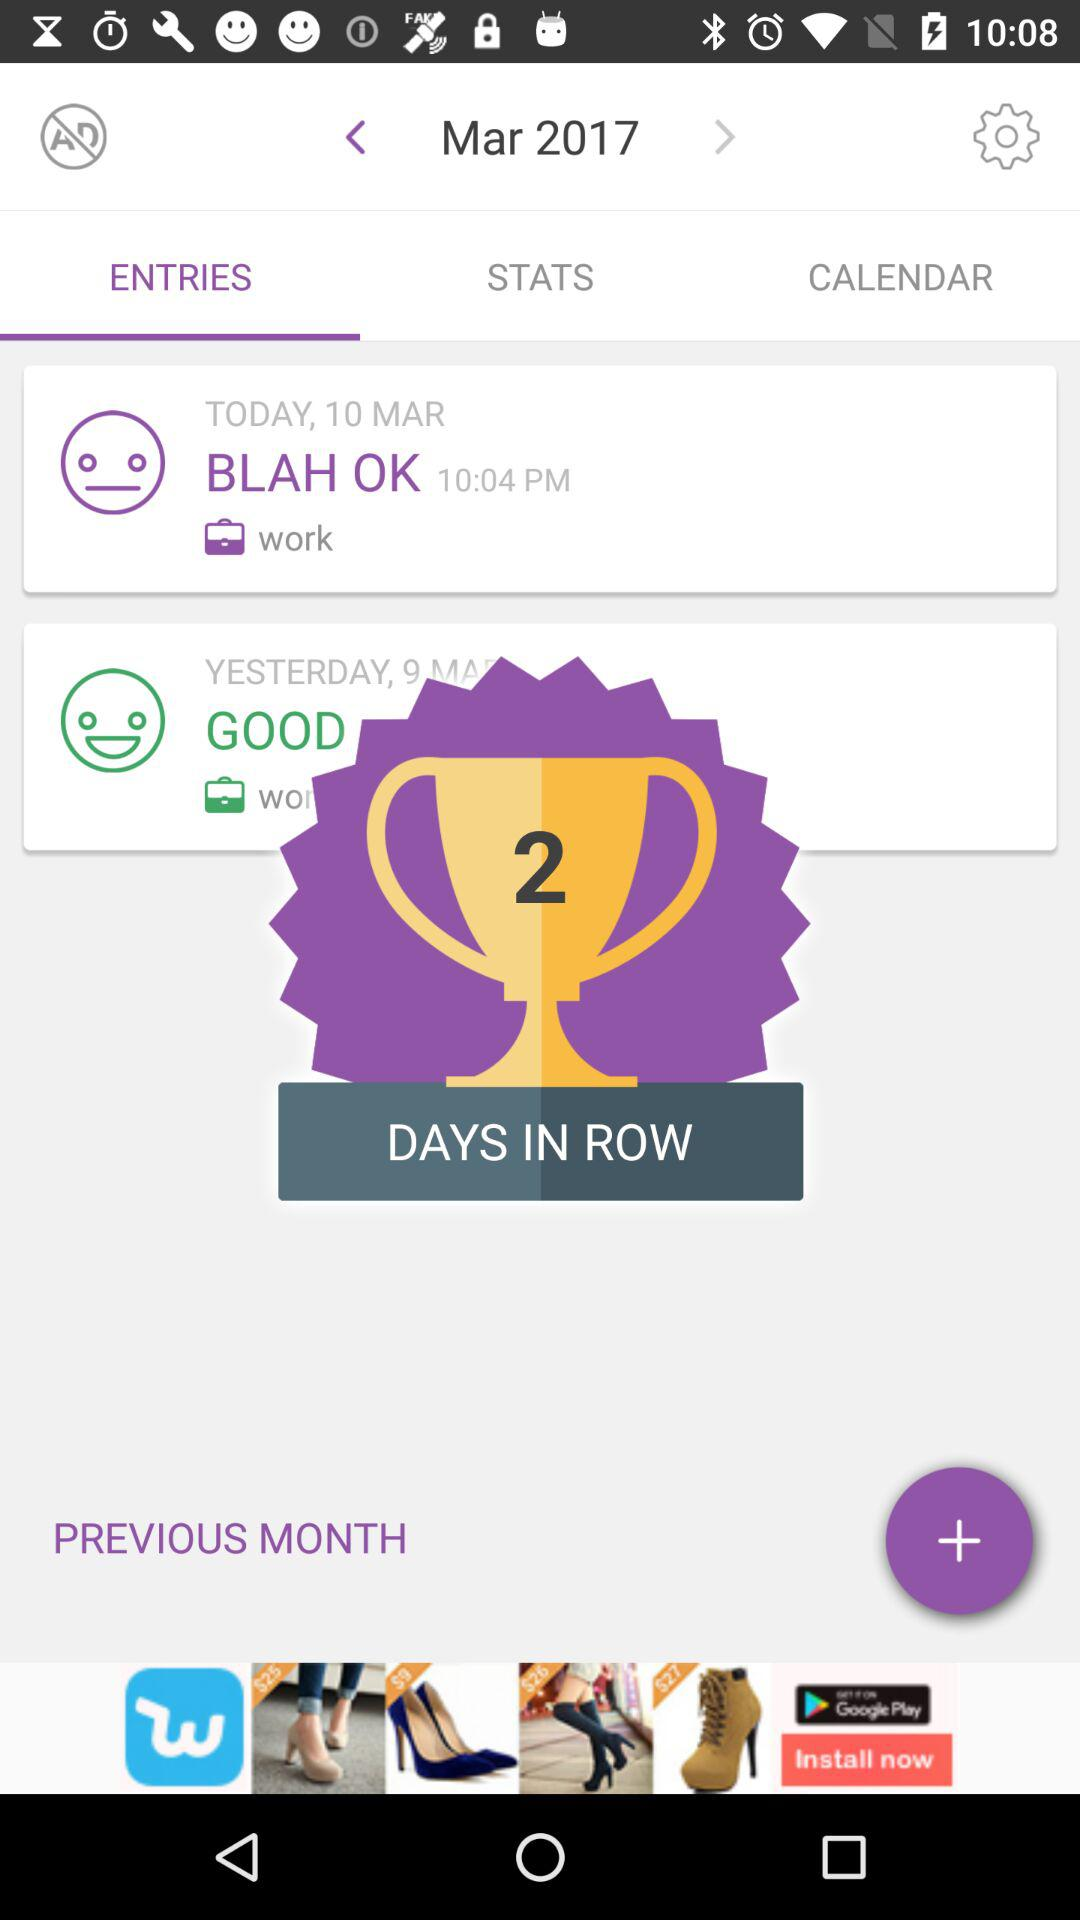What is the year? The year is 2017. 